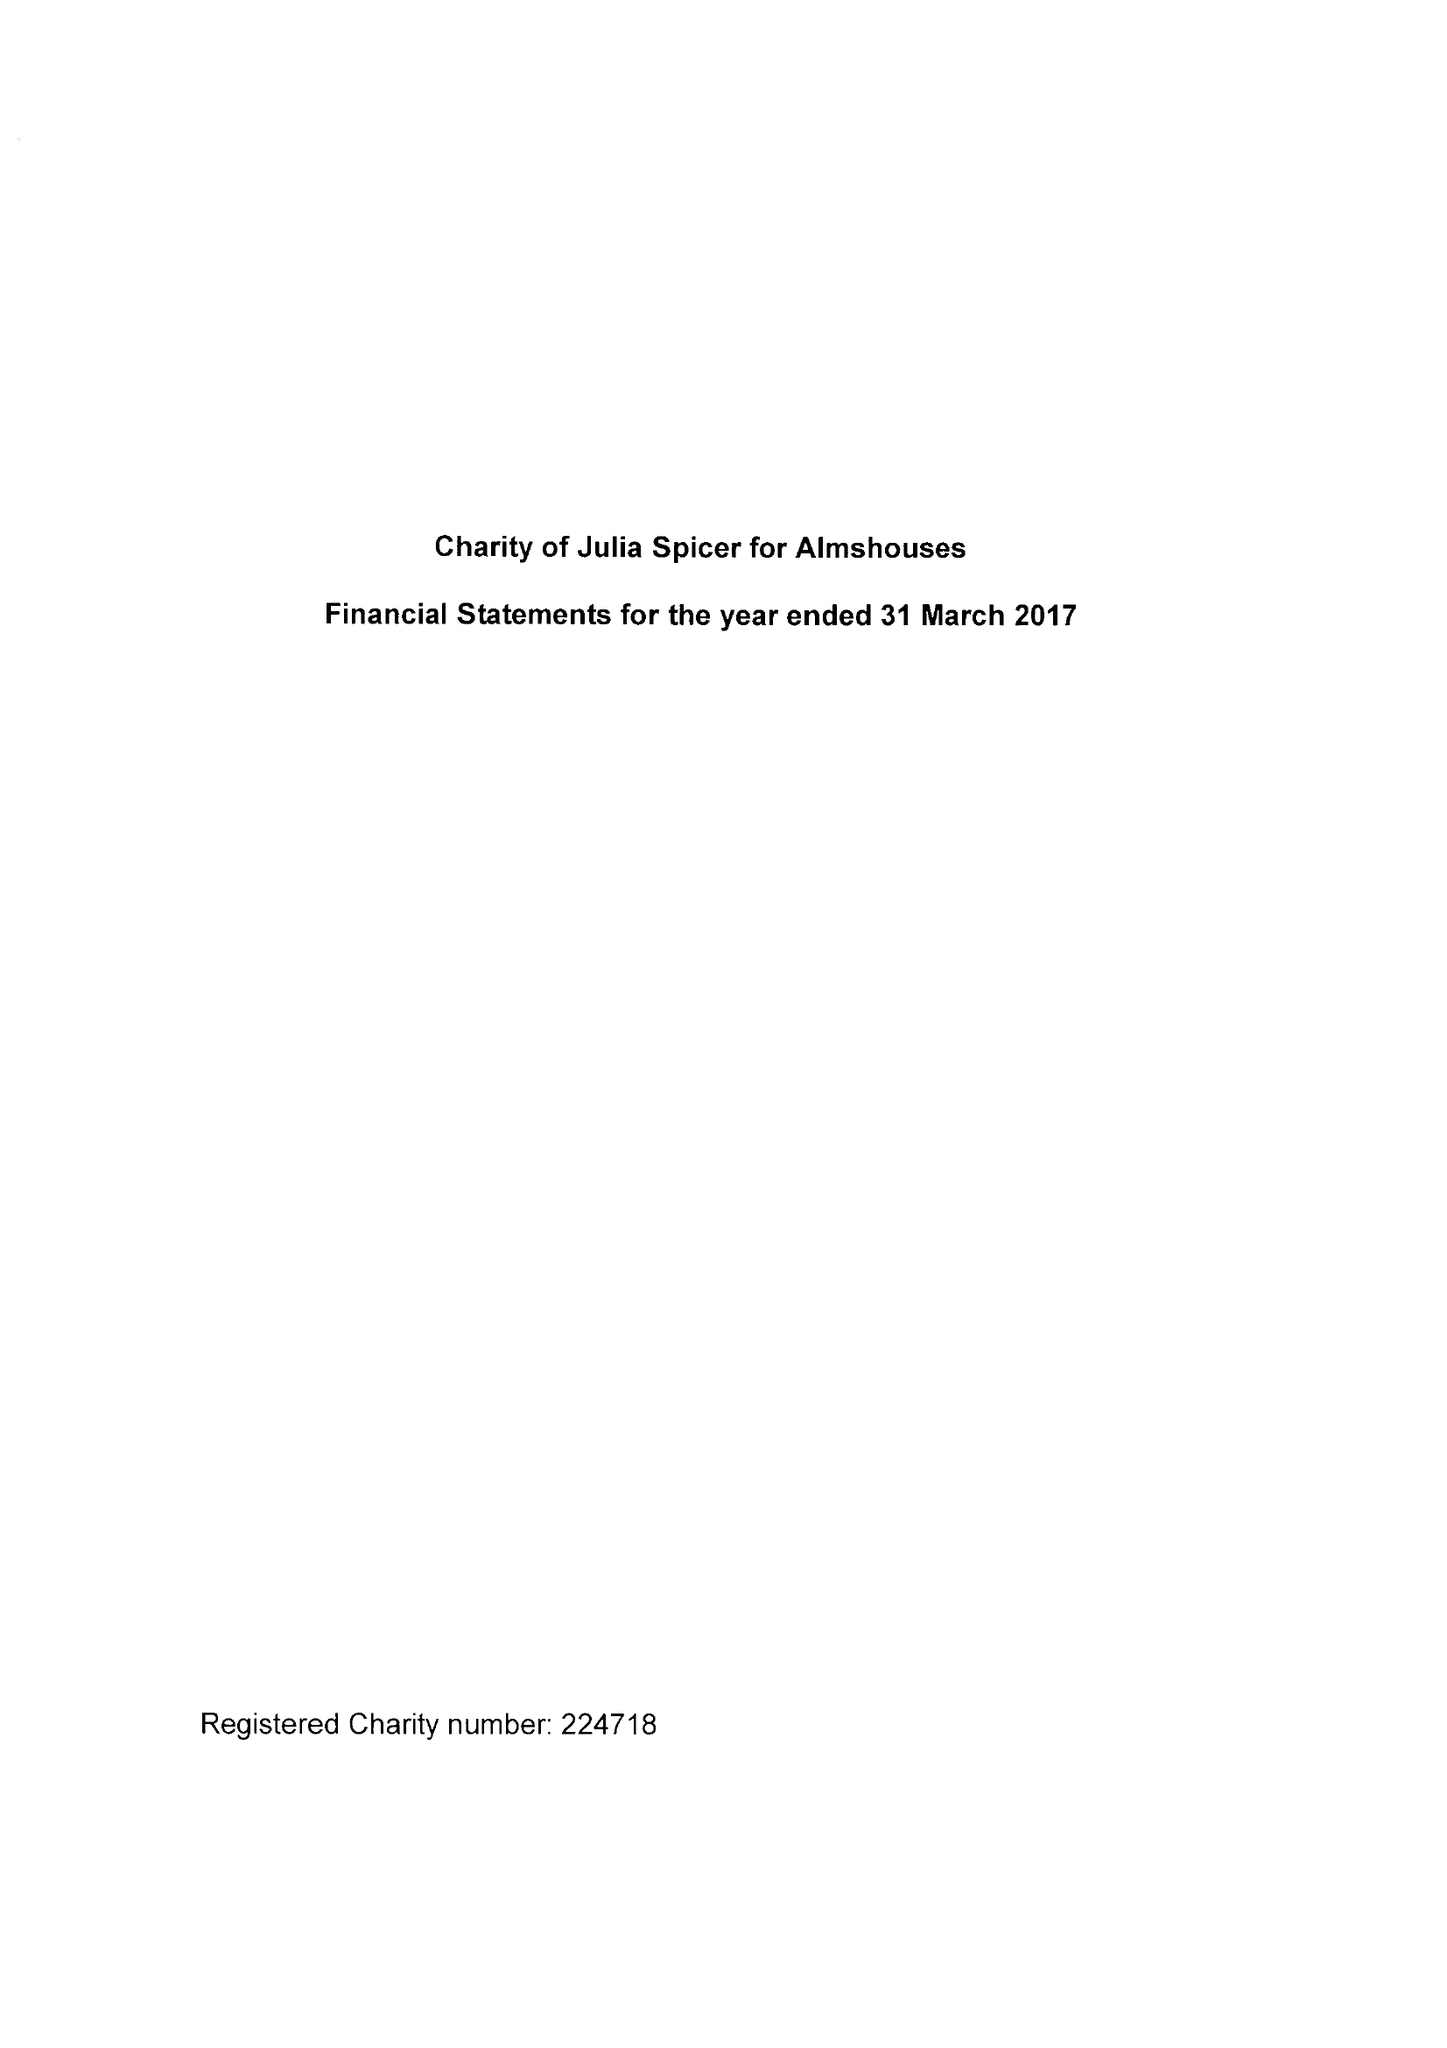What is the value for the spending_annually_in_british_pounds?
Answer the question using a single word or phrase. 29333.00 